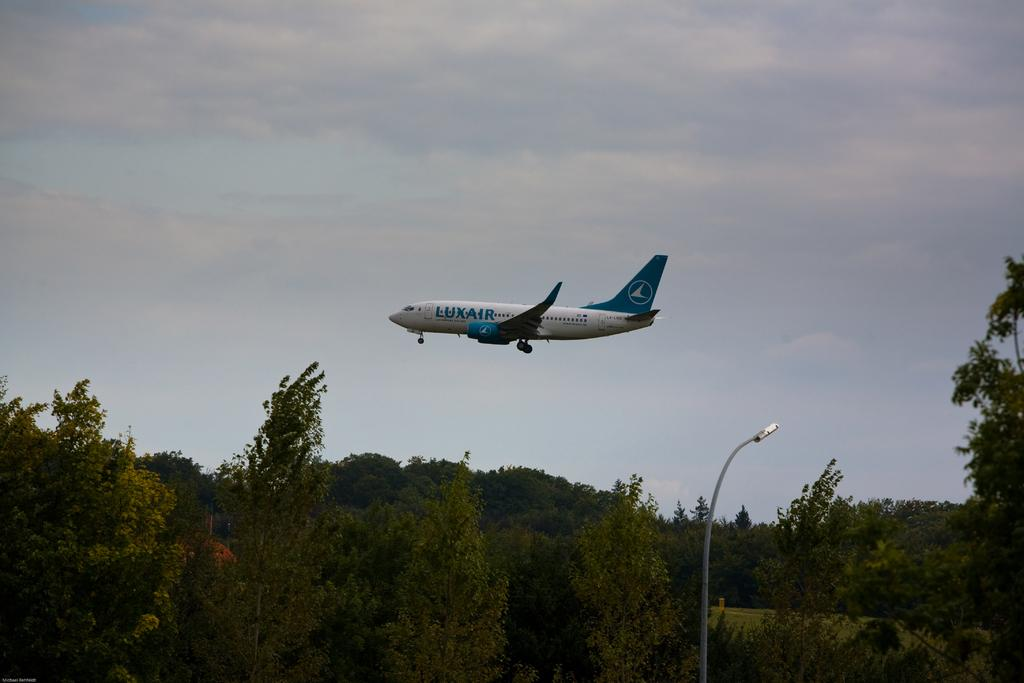<image>
Offer a succinct explanation of the picture presented. A LUXAIR plane is flying low above a forest 